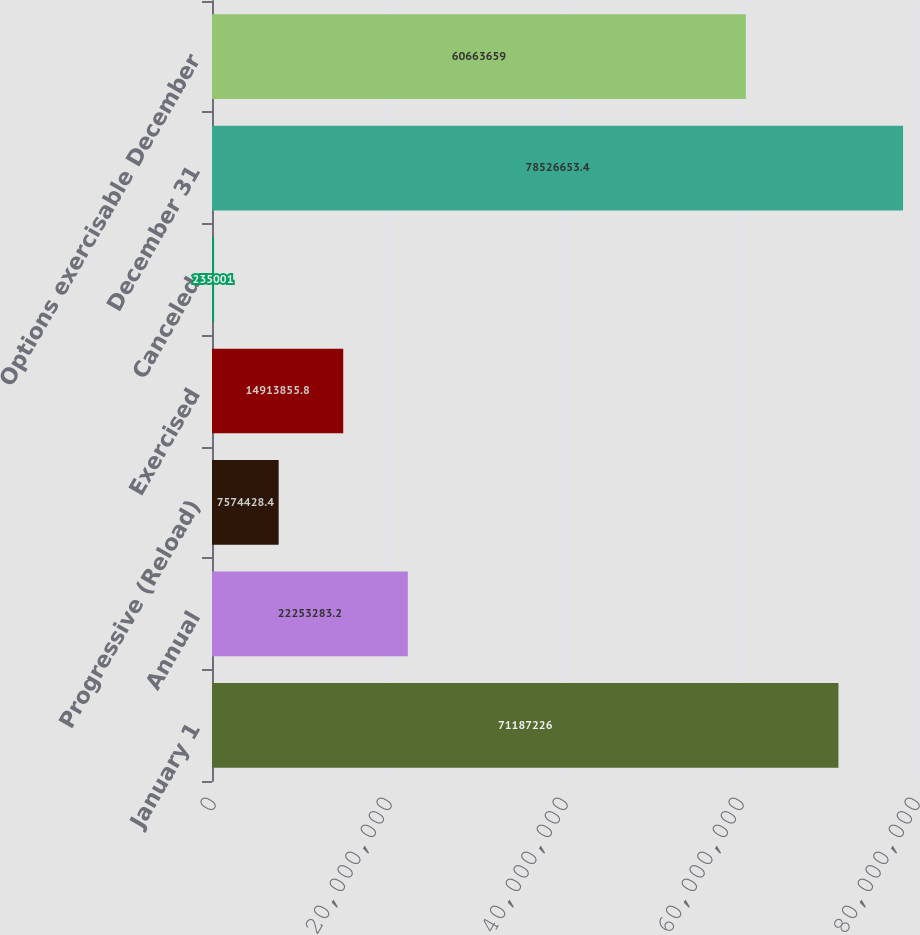Convert chart. <chart><loc_0><loc_0><loc_500><loc_500><bar_chart><fcel>January 1<fcel>Annual<fcel>Progressive (Reload)<fcel>Exercised<fcel>Canceled<fcel>December 31<fcel>Options exercisable December<nl><fcel>7.11872e+07<fcel>2.22533e+07<fcel>7.57443e+06<fcel>1.49139e+07<fcel>235001<fcel>7.85267e+07<fcel>6.06637e+07<nl></chart> 